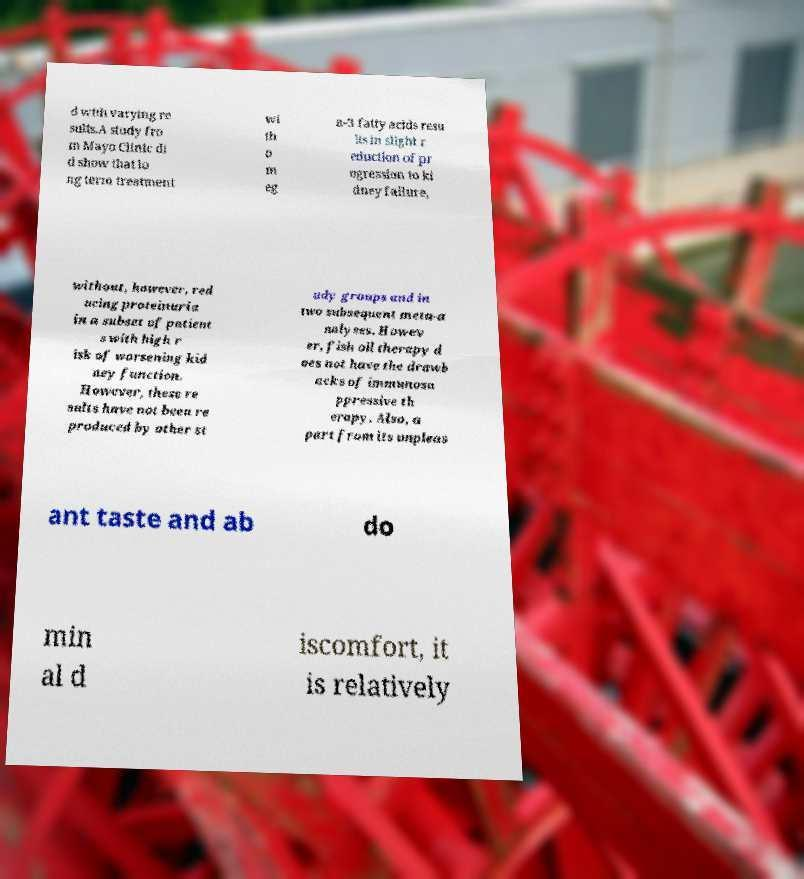Could you assist in decoding the text presented in this image and type it out clearly? d with varying re sults.A study fro m Mayo Clinic di d show that lo ng term treatment wi th o m eg a-3 fatty acids resu lts in slight r eduction of pr ogression to ki dney failure, without, however, red ucing proteinuria in a subset of patient s with high r isk of worsening kid ney function. However, these re sults have not been re produced by other st udy groups and in two subsequent meta-a nalyses. Howev er, fish oil therapy d oes not have the drawb acks of immunosu ppressive th erapy. Also, a part from its unpleas ant taste and ab do min al d iscomfort, it is relatively 